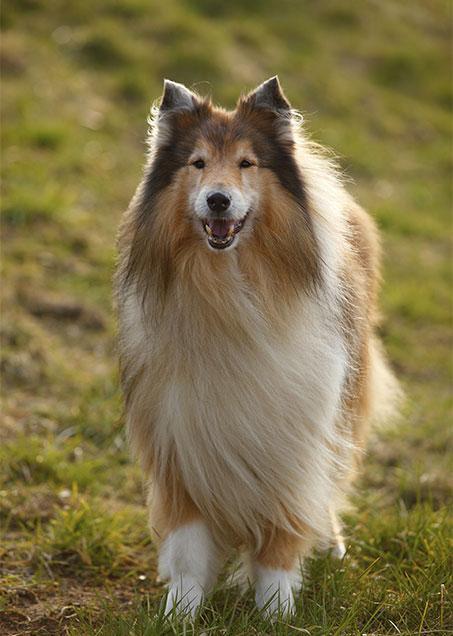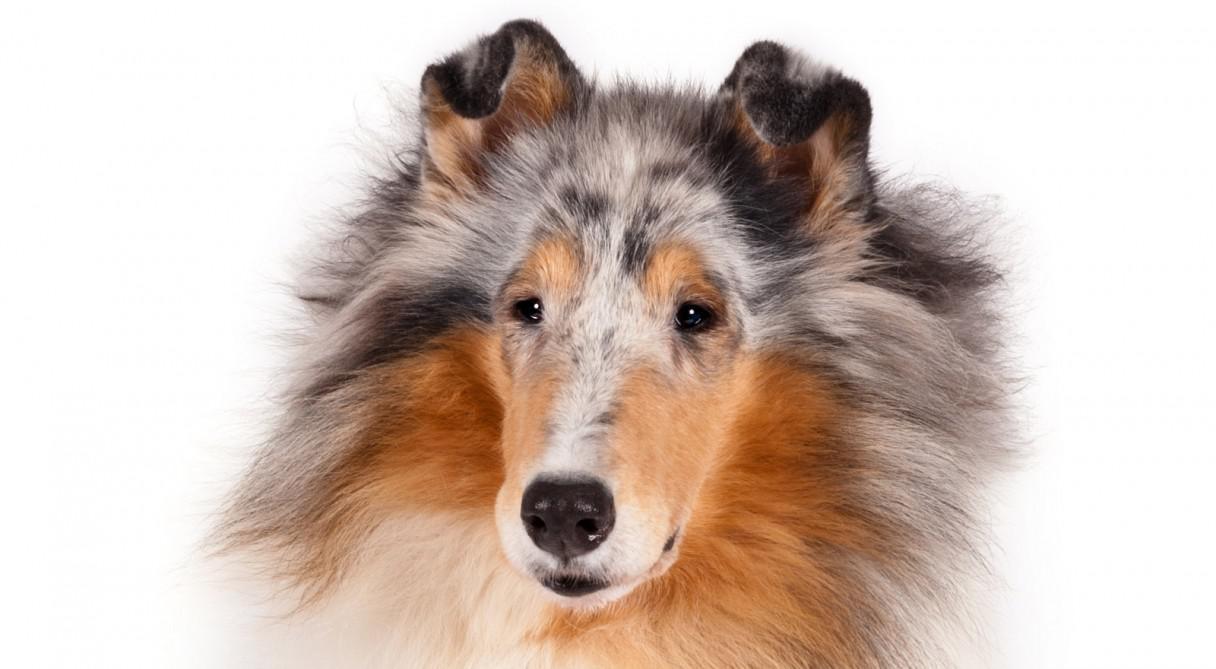The first image is the image on the left, the second image is the image on the right. For the images shown, is this caption "One image shows a collie standing on grass, and the other is a portrait." true? Answer yes or no. Yes. 